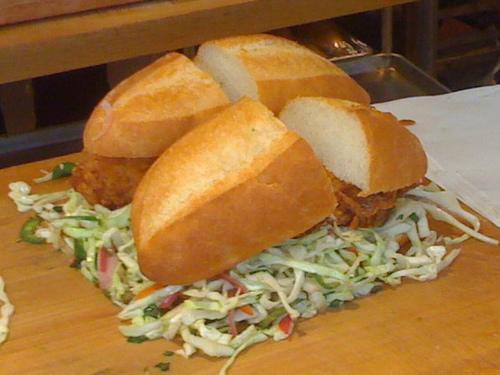How many sandwiches are shown?
Give a very brief answer. 2. How many sandwiches are sliced?
Give a very brief answer. 2. How many tables/counters can be seen?
Give a very brief answer. 2. How many sandwiches are pictured?
Give a very brief answer. 2. How many sandwich pieces are there?
Give a very brief answer. 4. How many sandwiches are there?
Give a very brief answer. 2. How many boys are in this picture?
Give a very brief answer. 0. 